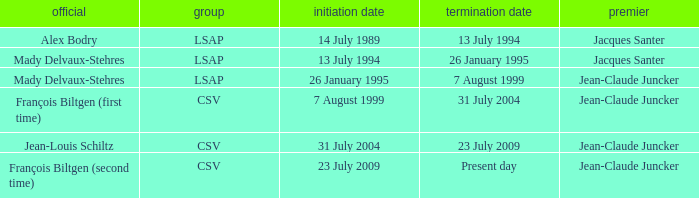Would you mind parsing the complete table? {'header': ['official', 'group', 'initiation date', 'termination date', 'premier'], 'rows': [['Alex Bodry', 'LSAP', '14 July 1989', '13 July 1994', 'Jacques Santer'], ['Mady Delvaux-Stehres', 'LSAP', '13 July 1994', '26 January 1995', 'Jacques Santer'], ['Mady Delvaux-Stehres', 'LSAP', '26 January 1995', '7 August 1999', 'Jean-Claude Juncker'], ['François Biltgen (first time)', 'CSV', '7 August 1999', '31 July 2004', 'Jean-Claude Juncker'], ['Jean-Louis Schiltz', 'CSV', '31 July 2004', '23 July 2009', 'Jean-Claude Juncker'], ['François Biltgen (second time)', 'CSV', '23 July 2009', 'Present day', 'Jean-Claude Juncker']]} What was the end date when Alex Bodry was the minister? 13 July 1994. 